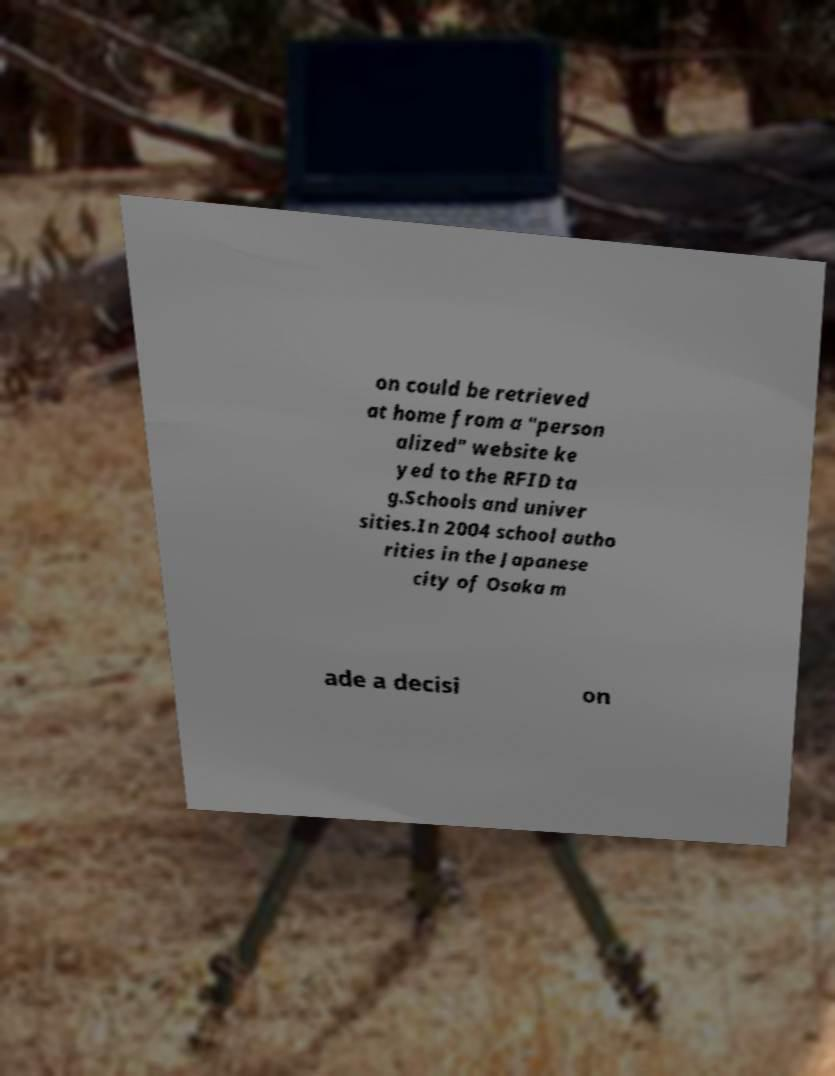Can you read and provide the text displayed in the image?This photo seems to have some interesting text. Can you extract and type it out for me? on could be retrieved at home from a "person alized" website ke yed to the RFID ta g.Schools and univer sities.In 2004 school autho rities in the Japanese city of Osaka m ade a decisi on 